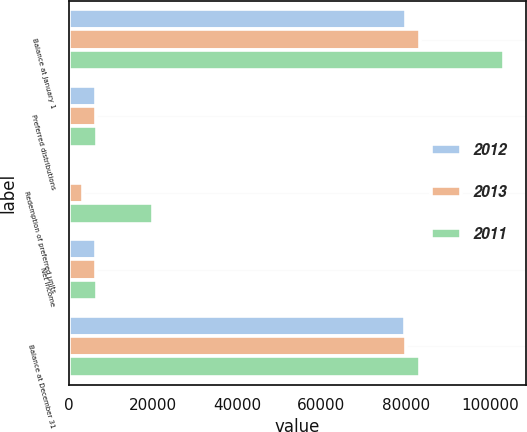Convert chart to OTSL. <chart><loc_0><loc_0><loc_500><loc_500><stacked_bar_chart><ecel><fcel>Balance at January 1<fcel>Preferred distributions<fcel>Redemption of preferred units<fcel>Net income<fcel>Balance at December 31<nl><fcel>2012<fcel>80046<fcel>6423<fcel>93<fcel>6423<fcel>79953<nl><fcel>2013<fcel>83384<fcel>6496<fcel>3338<fcel>6496<fcel>80046<nl><fcel>2011<fcel>103428<fcel>6683<fcel>20044<fcel>6683<fcel>83384<nl></chart> 